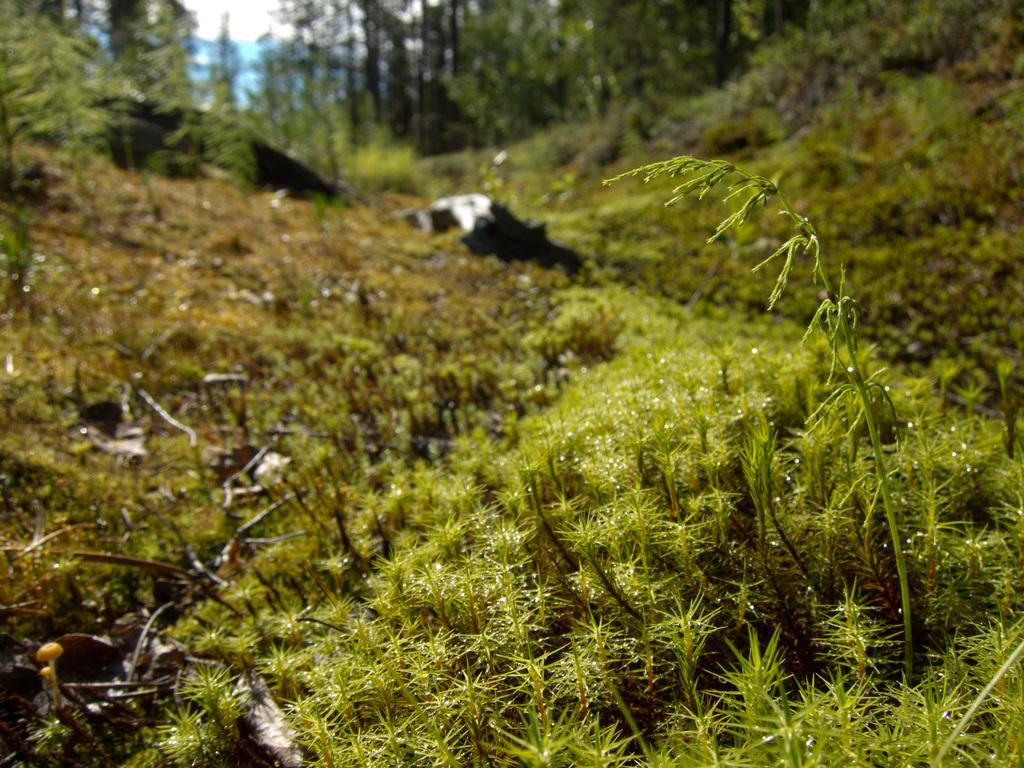What type of vegetation can be seen in the image? There are plants, shrubs, twigs, and grass visible in the image. What other natural elements can be seen in the image? There are rocks in the image. What is visible in the background of the image? There are trees and the sky visible in the background of the image. What letters can be seen on the rocks in the image? There are no letters visible on the rocks in the image. How much dust is present on the plants in the image? There is no information about dust on the plants in the image, so it cannot be determined. 